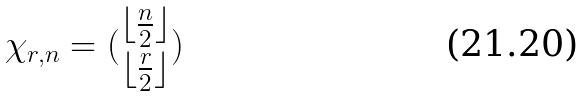<formula> <loc_0><loc_0><loc_500><loc_500>\chi _ { r , n } = ( \begin{matrix} \lfloor \frac { n } { 2 } \rfloor \\ \lfloor \frac { r } { 2 } \rfloor \end{matrix} )</formula> 